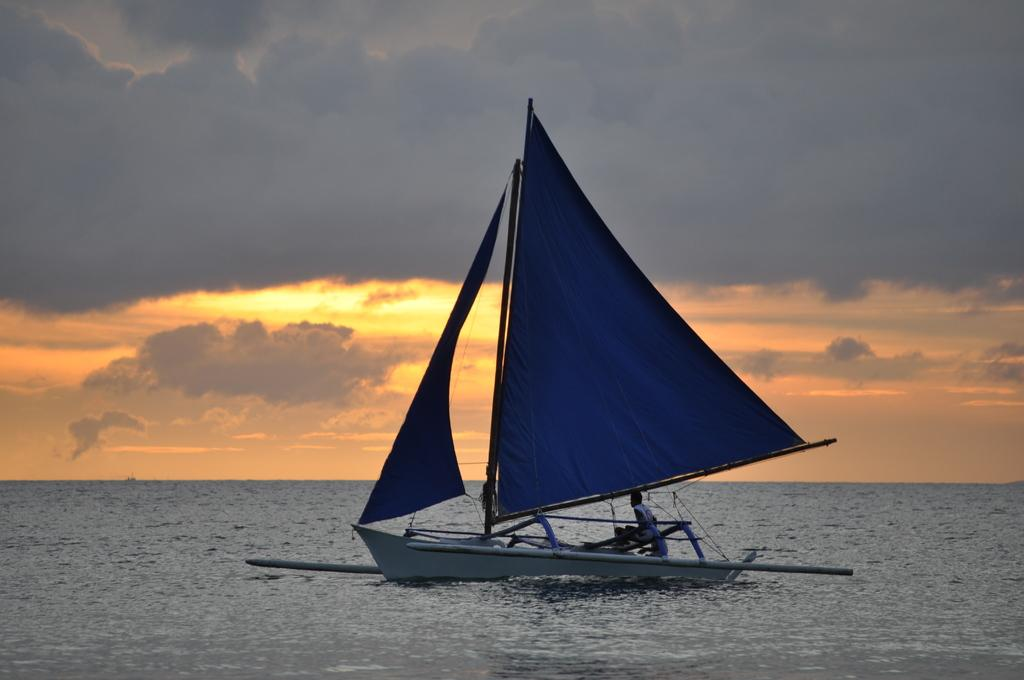What is the main setting of the picture? The main setting of the picture is an ocean. What can be seen in the water? There is a sailing ship in the water. How many people are on the ship? There are two persons in the ship. What is visible in the sky? There are clouds in the sky. What type of floor can be seen in the image? There is no floor present in the image, as it features an ocean and a sailing ship. What kind of yam is being used as a prop in the image? There is no yam present in the image. 